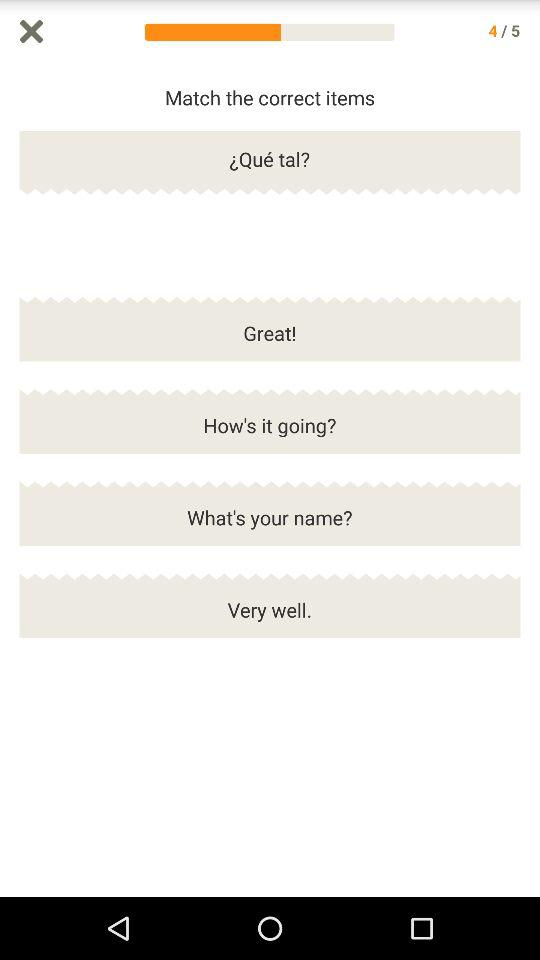How many total questions are there? The total number of questions is 5. 